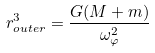Convert formula to latex. <formula><loc_0><loc_0><loc_500><loc_500>r _ { o u t e r } ^ { 3 } = { \frac { G ( M + m ) } { \omega _ { \varphi } ^ { 2 } } }</formula> 